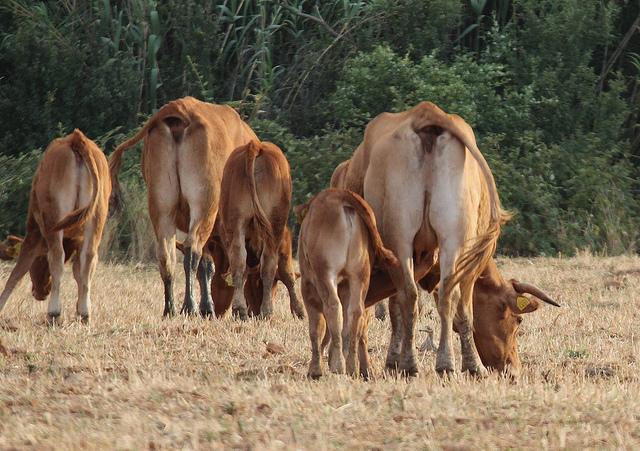How many cows are there?
Quick response, please. 5. What part of the animal is facing the photographer?
Give a very brief answer. Butt. Does any of the cows have horns?
Keep it brief. Yes. Are the animals hungry?
Short answer required. Yes. 